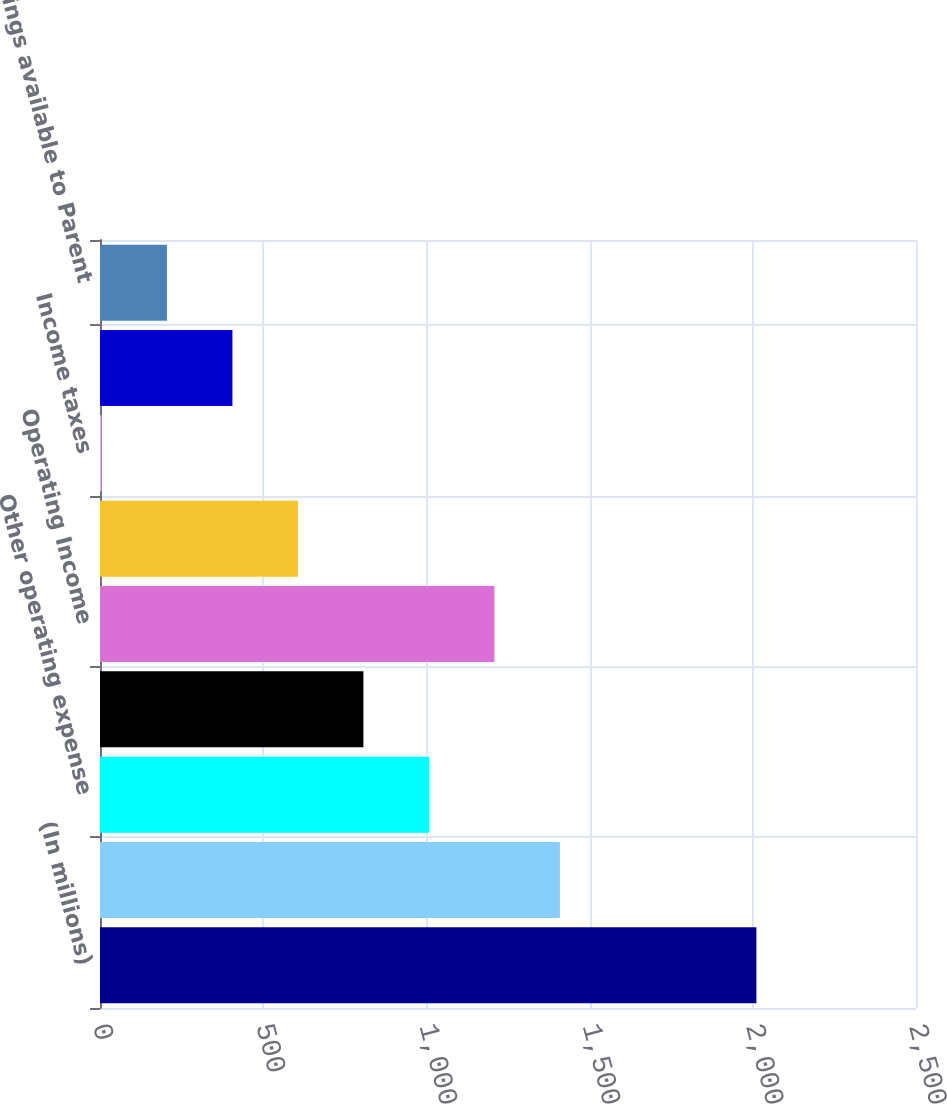<chart> <loc_0><loc_0><loc_500><loc_500><bar_chart><fcel>(In millions)<fcel>Revenues<fcel>Other operating expense<fcel>Provision for depreciation<fcel>Operating Income<fcel>Income before income taxes<fcel>Income taxes<fcel>Net Income<fcel>Earnings available to Parent<nl><fcel>2011<fcel>1409.02<fcel>1007.7<fcel>807.04<fcel>1208.36<fcel>606.38<fcel>4.4<fcel>405.72<fcel>205.06<nl></chart> 